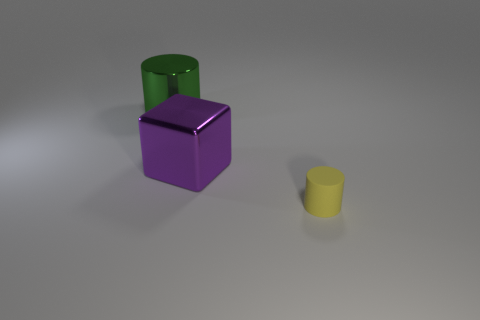Add 3 large objects. How many objects exist? 6 Subtract all cylinders. How many objects are left? 1 Subtract all big yellow balls. Subtract all tiny yellow matte cylinders. How many objects are left? 2 Add 1 purple cubes. How many purple cubes are left? 2 Add 3 big purple blocks. How many big purple blocks exist? 4 Subtract 0 brown cubes. How many objects are left? 3 